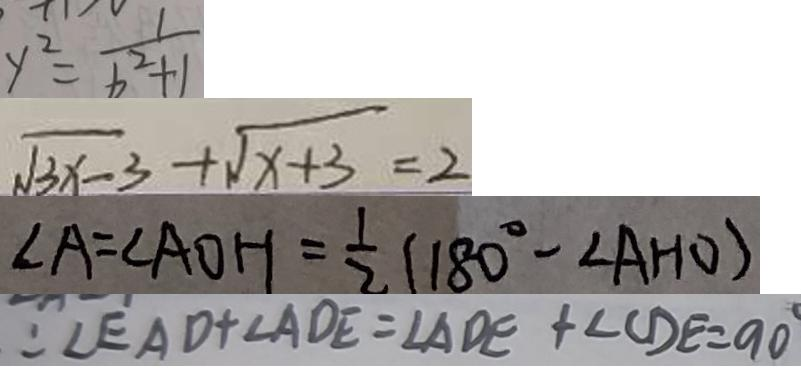Convert formula to latex. <formula><loc_0><loc_0><loc_500><loc_500>y ^ { 2 } = \frac { 1 } { b ^ { 2 } + 1 } 
 \sqrt { 3 x - 3 } + \sqrt { x + 3 } = 2 
 \angle A = \angle A O H = \frac { 1 } { 2 } ( 1 8 0 ^ { \circ } - \angle A H O ) 
 : \angle E A D + \angle A D E = \angle A D E + \angle C D E = 9 0 ^ { \circ }</formula> 